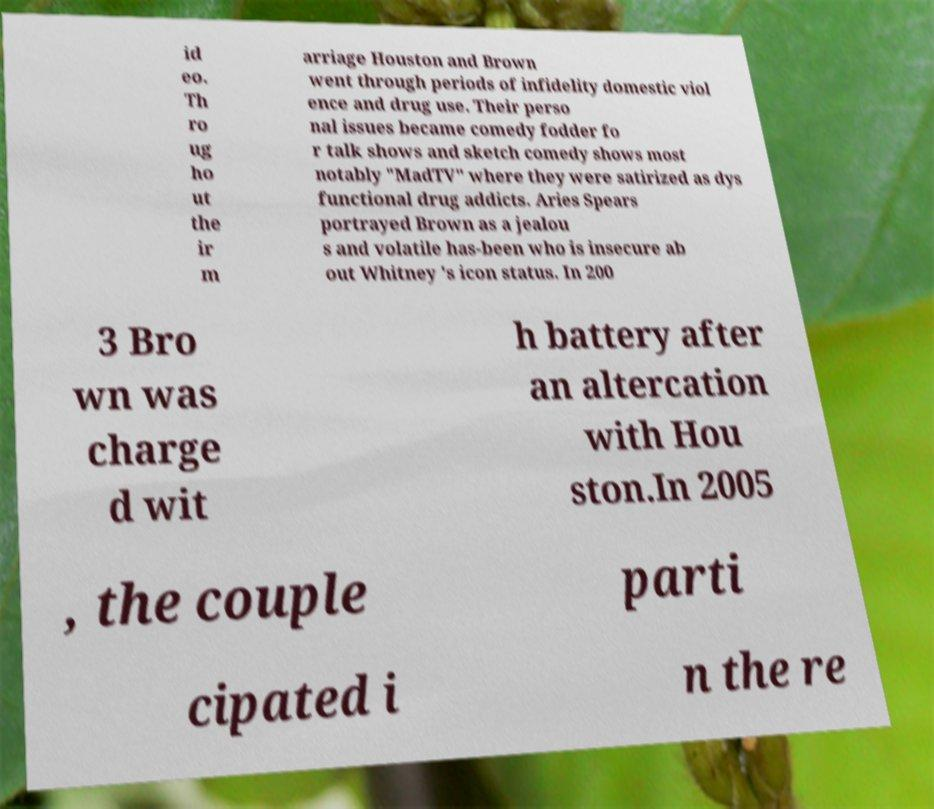Can you accurately transcribe the text from the provided image for me? id eo. Th ro ug ho ut the ir m arriage Houston and Brown went through periods of infidelity domestic viol ence and drug use. Their perso nal issues became comedy fodder fo r talk shows and sketch comedy shows most notably "MadTV" where they were satirized as dys functional drug addicts. Aries Spears portrayed Brown as a jealou s and volatile has-been who is insecure ab out Whitney 's icon status. In 200 3 Bro wn was charge d wit h battery after an altercation with Hou ston.In 2005 , the couple parti cipated i n the re 